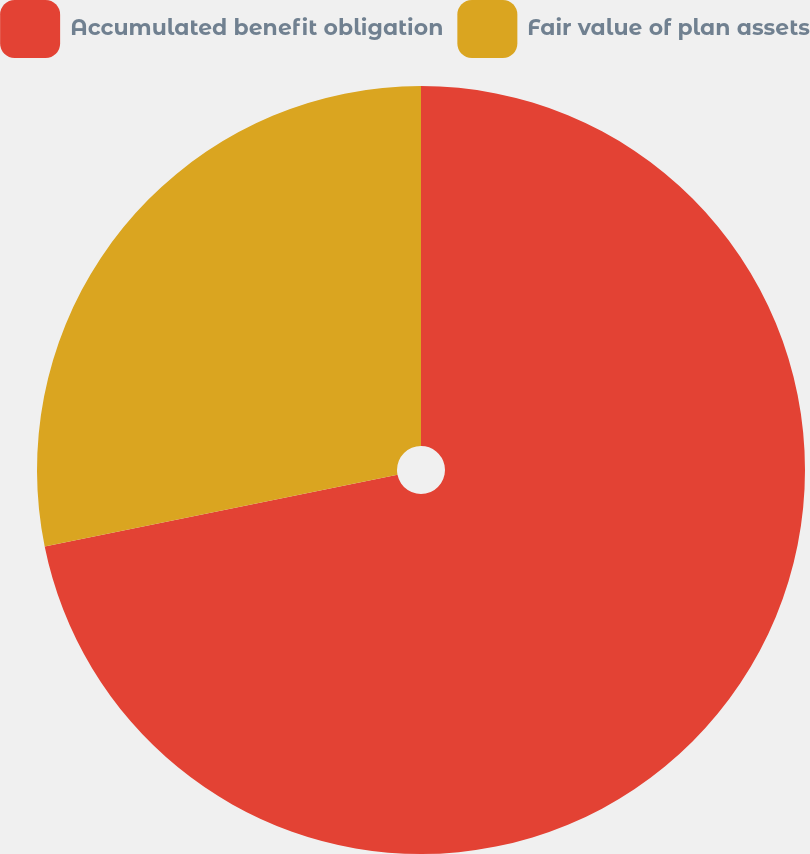Convert chart to OTSL. <chart><loc_0><loc_0><loc_500><loc_500><pie_chart><fcel>Accumulated benefit obligation<fcel>Fair value of plan assets<nl><fcel>71.81%<fcel>28.19%<nl></chart> 